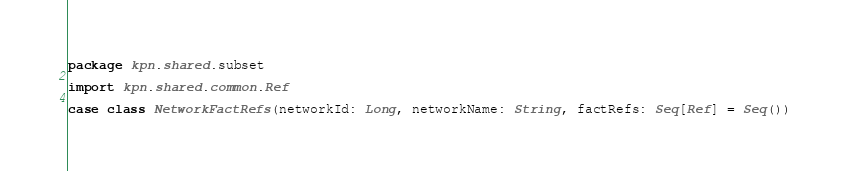Convert code to text. <code><loc_0><loc_0><loc_500><loc_500><_Scala_>package kpn.shared.subset

import kpn.shared.common.Ref

case class NetworkFactRefs(networkId: Long, networkName: String, factRefs: Seq[Ref] = Seq())
</code> 